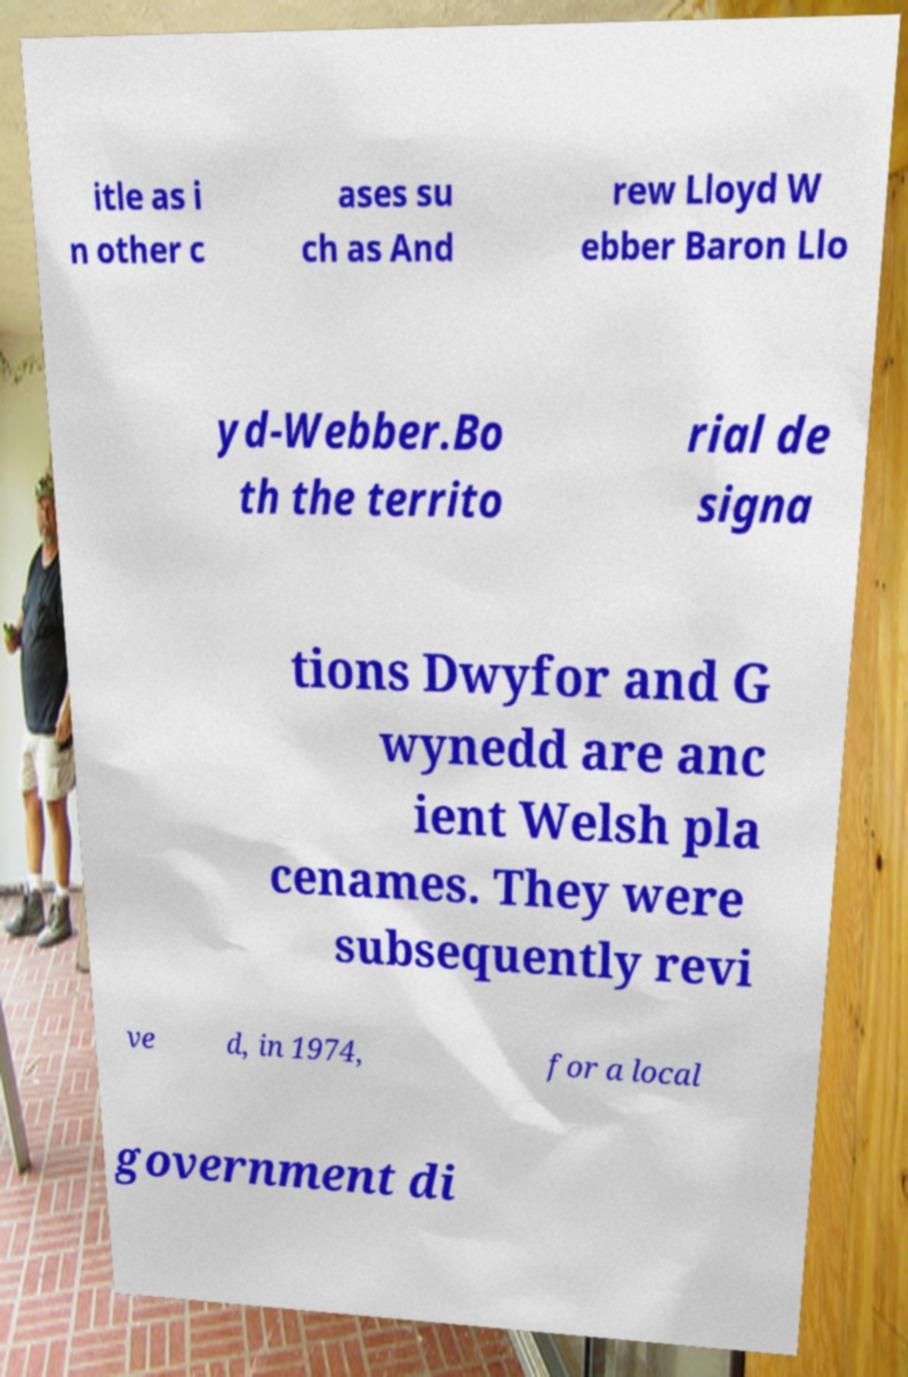Could you assist in decoding the text presented in this image and type it out clearly? itle as i n other c ases su ch as And rew Lloyd W ebber Baron Llo yd-Webber.Bo th the territo rial de signa tions Dwyfor and G wynedd are anc ient Welsh pla cenames. They were subsequently revi ve d, in 1974, for a local government di 